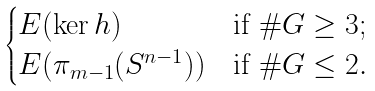<formula> <loc_0><loc_0><loc_500><loc_500>\begin{cases} E ( \ker h ) & \text {if } \# G \geq 3 ; \\ E ( \pi _ { m - 1 } ( S ^ { n - 1 } ) ) & \text {if } \# G \leq 2 . \end{cases}</formula> 